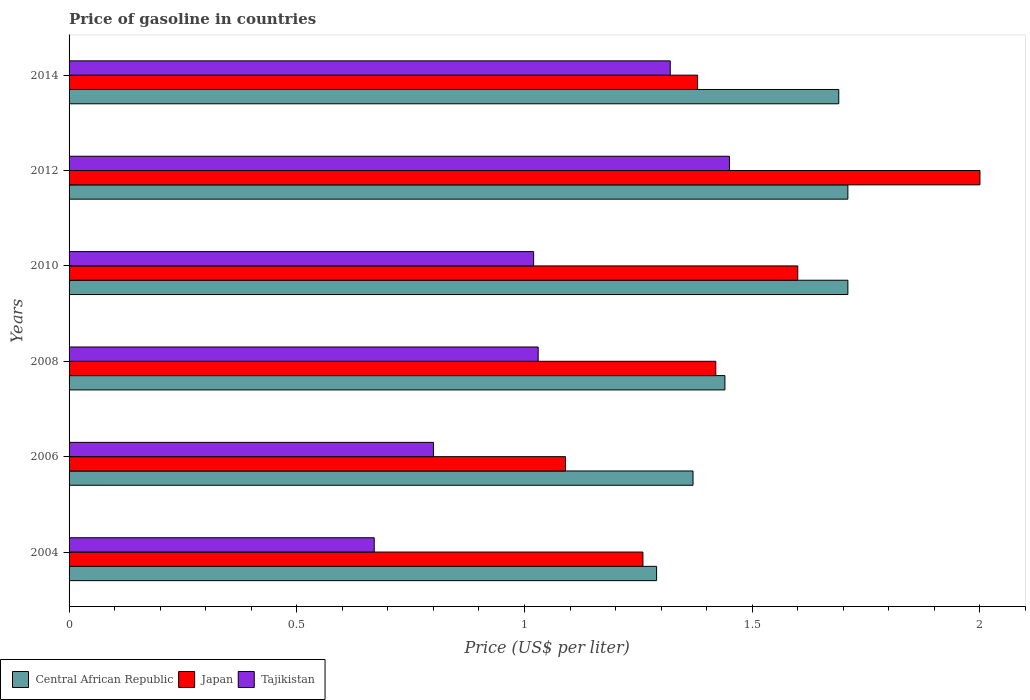Are the number of bars per tick equal to the number of legend labels?
Your answer should be compact. Yes. Across all years, what is the maximum price of gasoline in Tajikistan?
Ensure brevity in your answer.  1.45. Across all years, what is the minimum price of gasoline in Japan?
Give a very brief answer. 1.09. In which year was the price of gasoline in Central African Republic maximum?
Offer a very short reply. 2010. What is the total price of gasoline in Central African Republic in the graph?
Keep it short and to the point. 9.21. What is the difference between the price of gasoline in Tajikistan in 2004 and that in 2006?
Provide a succinct answer. -0.13. What is the difference between the price of gasoline in Tajikistan in 2004 and the price of gasoline in Central African Republic in 2012?
Ensure brevity in your answer.  -1.04. What is the average price of gasoline in Central African Republic per year?
Your response must be concise. 1.53. In the year 2010, what is the difference between the price of gasoline in Tajikistan and price of gasoline in Central African Republic?
Your answer should be compact. -0.69. In how many years, is the price of gasoline in Japan greater than 2 US$?
Offer a very short reply. 0. What is the ratio of the price of gasoline in Japan in 2004 to that in 2014?
Your answer should be compact. 0.91. Is the price of gasoline in Japan in 2010 less than that in 2014?
Your response must be concise. No. Is the difference between the price of gasoline in Tajikistan in 2010 and 2012 greater than the difference between the price of gasoline in Central African Republic in 2010 and 2012?
Give a very brief answer. No. What is the difference between the highest and the second highest price of gasoline in Japan?
Make the answer very short. 0.4. What is the difference between the highest and the lowest price of gasoline in Japan?
Your answer should be very brief. 0.91. Is the sum of the price of gasoline in Central African Republic in 2004 and 2012 greater than the maximum price of gasoline in Tajikistan across all years?
Your answer should be compact. Yes. What does the 2nd bar from the top in 2004 represents?
Provide a succinct answer. Japan. What does the 3rd bar from the bottom in 2014 represents?
Make the answer very short. Tajikistan. Is it the case that in every year, the sum of the price of gasoline in Japan and price of gasoline in Tajikistan is greater than the price of gasoline in Central African Republic?
Offer a terse response. Yes. How many years are there in the graph?
Make the answer very short. 6. What is the difference between two consecutive major ticks on the X-axis?
Give a very brief answer. 0.5. Are the values on the major ticks of X-axis written in scientific E-notation?
Your answer should be very brief. No. Does the graph contain any zero values?
Your answer should be very brief. No. Does the graph contain grids?
Your response must be concise. No. Where does the legend appear in the graph?
Your answer should be compact. Bottom left. How many legend labels are there?
Offer a terse response. 3. What is the title of the graph?
Ensure brevity in your answer.  Price of gasoline in countries. Does "Macedonia" appear as one of the legend labels in the graph?
Your response must be concise. No. What is the label or title of the X-axis?
Your answer should be compact. Price (US$ per liter). What is the Price (US$ per liter) in Central African Republic in 2004?
Keep it short and to the point. 1.29. What is the Price (US$ per liter) in Japan in 2004?
Ensure brevity in your answer.  1.26. What is the Price (US$ per liter) of Tajikistan in 2004?
Offer a very short reply. 0.67. What is the Price (US$ per liter) of Central African Republic in 2006?
Offer a terse response. 1.37. What is the Price (US$ per liter) of Japan in 2006?
Give a very brief answer. 1.09. What is the Price (US$ per liter) in Tajikistan in 2006?
Your answer should be compact. 0.8. What is the Price (US$ per liter) in Central African Republic in 2008?
Give a very brief answer. 1.44. What is the Price (US$ per liter) in Japan in 2008?
Give a very brief answer. 1.42. What is the Price (US$ per liter) in Tajikistan in 2008?
Provide a succinct answer. 1.03. What is the Price (US$ per liter) of Central African Republic in 2010?
Keep it short and to the point. 1.71. What is the Price (US$ per liter) in Tajikistan in 2010?
Provide a short and direct response. 1.02. What is the Price (US$ per liter) in Central African Republic in 2012?
Your response must be concise. 1.71. What is the Price (US$ per liter) in Japan in 2012?
Offer a terse response. 2. What is the Price (US$ per liter) in Tajikistan in 2012?
Your response must be concise. 1.45. What is the Price (US$ per liter) in Central African Republic in 2014?
Offer a very short reply. 1.69. What is the Price (US$ per liter) in Japan in 2014?
Your answer should be compact. 1.38. What is the Price (US$ per liter) in Tajikistan in 2014?
Make the answer very short. 1.32. Across all years, what is the maximum Price (US$ per liter) of Central African Republic?
Ensure brevity in your answer.  1.71. Across all years, what is the maximum Price (US$ per liter) of Japan?
Offer a terse response. 2. Across all years, what is the maximum Price (US$ per liter) of Tajikistan?
Provide a succinct answer. 1.45. Across all years, what is the minimum Price (US$ per liter) of Central African Republic?
Make the answer very short. 1.29. Across all years, what is the minimum Price (US$ per liter) in Japan?
Keep it short and to the point. 1.09. Across all years, what is the minimum Price (US$ per liter) of Tajikistan?
Give a very brief answer. 0.67. What is the total Price (US$ per liter) of Central African Republic in the graph?
Your answer should be very brief. 9.21. What is the total Price (US$ per liter) in Japan in the graph?
Ensure brevity in your answer.  8.75. What is the total Price (US$ per liter) of Tajikistan in the graph?
Provide a short and direct response. 6.29. What is the difference between the Price (US$ per liter) of Central African Republic in 2004 and that in 2006?
Offer a terse response. -0.08. What is the difference between the Price (US$ per liter) of Japan in 2004 and that in 2006?
Provide a short and direct response. 0.17. What is the difference between the Price (US$ per liter) in Tajikistan in 2004 and that in 2006?
Keep it short and to the point. -0.13. What is the difference between the Price (US$ per liter) in Japan in 2004 and that in 2008?
Make the answer very short. -0.16. What is the difference between the Price (US$ per liter) in Tajikistan in 2004 and that in 2008?
Provide a short and direct response. -0.36. What is the difference between the Price (US$ per liter) of Central African Republic in 2004 and that in 2010?
Provide a succinct answer. -0.42. What is the difference between the Price (US$ per liter) of Japan in 2004 and that in 2010?
Your response must be concise. -0.34. What is the difference between the Price (US$ per liter) in Tajikistan in 2004 and that in 2010?
Provide a succinct answer. -0.35. What is the difference between the Price (US$ per liter) in Central African Republic in 2004 and that in 2012?
Give a very brief answer. -0.42. What is the difference between the Price (US$ per liter) in Japan in 2004 and that in 2012?
Offer a terse response. -0.74. What is the difference between the Price (US$ per liter) of Tajikistan in 2004 and that in 2012?
Make the answer very short. -0.78. What is the difference between the Price (US$ per liter) in Central African Republic in 2004 and that in 2014?
Make the answer very short. -0.4. What is the difference between the Price (US$ per liter) of Japan in 2004 and that in 2014?
Provide a succinct answer. -0.12. What is the difference between the Price (US$ per liter) in Tajikistan in 2004 and that in 2014?
Provide a succinct answer. -0.65. What is the difference between the Price (US$ per liter) in Central African Republic in 2006 and that in 2008?
Offer a terse response. -0.07. What is the difference between the Price (US$ per liter) in Japan in 2006 and that in 2008?
Keep it short and to the point. -0.33. What is the difference between the Price (US$ per liter) of Tajikistan in 2006 and that in 2008?
Offer a terse response. -0.23. What is the difference between the Price (US$ per liter) in Central African Republic in 2006 and that in 2010?
Ensure brevity in your answer.  -0.34. What is the difference between the Price (US$ per liter) of Japan in 2006 and that in 2010?
Make the answer very short. -0.51. What is the difference between the Price (US$ per liter) of Tajikistan in 2006 and that in 2010?
Provide a succinct answer. -0.22. What is the difference between the Price (US$ per liter) of Central African Republic in 2006 and that in 2012?
Offer a terse response. -0.34. What is the difference between the Price (US$ per liter) of Japan in 2006 and that in 2012?
Your answer should be very brief. -0.91. What is the difference between the Price (US$ per liter) in Tajikistan in 2006 and that in 2012?
Your answer should be very brief. -0.65. What is the difference between the Price (US$ per liter) in Central African Republic in 2006 and that in 2014?
Offer a terse response. -0.32. What is the difference between the Price (US$ per liter) in Japan in 2006 and that in 2014?
Keep it short and to the point. -0.29. What is the difference between the Price (US$ per liter) in Tajikistan in 2006 and that in 2014?
Keep it short and to the point. -0.52. What is the difference between the Price (US$ per liter) of Central African Republic in 2008 and that in 2010?
Keep it short and to the point. -0.27. What is the difference between the Price (US$ per liter) in Japan in 2008 and that in 2010?
Provide a short and direct response. -0.18. What is the difference between the Price (US$ per liter) in Central African Republic in 2008 and that in 2012?
Your response must be concise. -0.27. What is the difference between the Price (US$ per liter) in Japan in 2008 and that in 2012?
Offer a very short reply. -0.58. What is the difference between the Price (US$ per liter) of Tajikistan in 2008 and that in 2012?
Your response must be concise. -0.42. What is the difference between the Price (US$ per liter) of Tajikistan in 2008 and that in 2014?
Ensure brevity in your answer.  -0.29. What is the difference between the Price (US$ per liter) of Central African Republic in 2010 and that in 2012?
Give a very brief answer. 0. What is the difference between the Price (US$ per liter) in Japan in 2010 and that in 2012?
Provide a succinct answer. -0.4. What is the difference between the Price (US$ per liter) of Tajikistan in 2010 and that in 2012?
Give a very brief answer. -0.43. What is the difference between the Price (US$ per liter) in Japan in 2010 and that in 2014?
Offer a very short reply. 0.22. What is the difference between the Price (US$ per liter) of Tajikistan in 2010 and that in 2014?
Provide a succinct answer. -0.3. What is the difference between the Price (US$ per liter) of Japan in 2012 and that in 2014?
Provide a short and direct response. 0.62. What is the difference between the Price (US$ per liter) in Tajikistan in 2012 and that in 2014?
Your answer should be very brief. 0.13. What is the difference between the Price (US$ per liter) of Central African Republic in 2004 and the Price (US$ per liter) of Japan in 2006?
Your answer should be compact. 0.2. What is the difference between the Price (US$ per liter) in Central African Republic in 2004 and the Price (US$ per liter) in Tajikistan in 2006?
Your answer should be compact. 0.49. What is the difference between the Price (US$ per liter) of Japan in 2004 and the Price (US$ per liter) of Tajikistan in 2006?
Your response must be concise. 0.46. What is the difference between the Price (US$ per liter) in Central African Republic in 2004 and the Price (US$ per liter) in Japan in 2008?
Keep it short and to the point. -0.13. What is the difference between the Price (US$ per liter) in Central African Republic in 2004 and the Price (US$ per liter) in Tajikistan in 2008?
Offer a terse response. 0.26. What is the difference between the Price (US$ per liter) of Japan in 2004 and the Price (US$ per liter) of Tajikistan in 2008?
Provide a succinct answer. 0.23. What is the difference between the Price (US$ per liter) in Central African Republic in 2004 and the Price (US$ per liter) in Japan in 2010?
Make the answer very short. -0.31. What is the difference between the Price (US$ per liter) of Central African Republic in 2004 and the Price (US$ per liter) of Tajikistan in 2010?
Your answer should be compact. 0.27. What is the difference between the Price (US$ per liter) of Japan in 2004 and the Price (US$ per liter) of Tajikistan in 2010?
Give a very brief answer. 0.24. What is the difference between the Price (US$ per liter) of Central African Republic in 2004 and the Price (US$ per liter) of Japan in 2012?
Your answer should be compact. -0.71. What is the difference between the Price (US$ per liter) of Central African Republic in 2004 and the Price (US$ per liter) of Tajikistan in 2012?
Offer a very short reply. -0.16. What is the difference between the Price (US$ per liter) in Japan in 2004 and the Price (US$ per liter) in Tajikistan in 2012?
Offer a very short reply. -0.19. What is the difference between the Price (US$ per liter) of Central African Republic in 2004 and the Price (US$ per liter) of Japan in 2014?
Offer a terse response. -0.09. What is the difference between the Price (US$ per liter) of Central African Republic in 2004 and the Price (US$ per liter) of Tajikistan in 2014?
Provide a short and direct response. -0.03. What is the difference between the Price (US$ per liter) in Japan in 2004 and the Price (US$ per liter) in Tajikistan in 2014?
Your answer should be compact. -0.06. What is the difference between the Price (US$ per liter) in Central African Republic in 2006 and the Price (US$ per liter) in Tajikistan in 2008?
Your response must be concise. 0.34. What is the difference between the Price (US$ per liter) of Japan in 2006 and the Price (US$ per liter) of Tajikistan in 2008?
Give a very brief answer. 0.06. What is the difference between the Price (US$ per liter) of Central African Republic in 2006 and the Price (US$ per liter) of Japan in 2010?
Make the answer very short. -0.23. What is the difference between the Price (US$ per liter) of Japan in 2006 and the Price (US$ per liter) of Tajikistan in 2010?
Provide a short and direct response. 0.07. What is the difference between the Price (US$ per liter) in Central African Republic in 2006 and the Price (US$ per liter) in Japan in 2012?
Offer a very short reply. -0.63. What is the difference between the Price (US$ per liter) in Central African Republic in 2006 and the Price (US$ per liter) in Tajikistan in 2012?
Provide a short and direct response. -0.08. What is the difference between the Price (US$ per liter) of Japan in 2006 and the Price (US$ per liter) of Tajikistan in 2012?
Make the answer very short. -0.36. What is the difference between the Price (US$ per liter) in Central African Republic in 2006 and the Price (US$ per liter) in Japan in 2014?
Offer a very short reply. -0.01. What is the difference between the Price (US$ per liter) of Japan in 2006 and the Price (US$ per liter) of Tajikistan in 2014?
Give a very brief answer. -0.23. What is the difference between the Price (US$ per liter) of Central African Republic in 2008 and the Price (US$ per liter) of Japan in 2010?
Provide a succinct answer. -0.16. What is the difference between the Price (US$ per liter) of Central African Republic in 2008 and the Price (US$ per liter) of Tajikistan in 2010?
Provide a short and direct response. 0.42. What is the difference between the Price (US$ per liter) of Central African Republic in 2008 and the Price (US$ per liter) of Japan in 2012?
Your response must be concise. -0.56. What is the difference between the Price (US$ per liter) of Central African Republic in 2008 and the Price (US$ per liter) of Tajikistan in 2012?
Make the answer very short. -0.01. What is the difference between the Price (US$ per liter) of Japan in 2008 and the Price (US$ per liter) of Tajikistan in 2012?
Offer a terse response. -0.03. What is the difference between the Price (US$ per liter) in Central African Republic in 2008 and the Price (US$ per liter) in Japan in 2014?
Offer a terse response. 0.06. What is the difference between the Price (US$ per liter) in Central African Republic in 2008 and the Price (US$ per liter) in Tajikistan in 2014?
Your answer should be very brief. 0.12. What is the difference between the Price (US$ per liter) in Central African Republic in 2010 and the Price (US$ per liter) in Japan in 2012?
Offer a terse response. -0.29. What is the difference between the Price (US$ per liter) of Central African Republic in 2010 and the Price (US$ per liter) of Tajikistan in 2012?
Make the answer very short. 0.26. What is the difference between the Price (US$ per liter) in Central African Republic in 2010 and the Price (US$ per liter) in Japan in 2014?
Keep it short and to the point. 0.33. What is the difference between the Price (US$ per liter) of Central African Republic in 2010 and the Price (US$ per liter) of Tajikistan in 2014?
Your response must be concise. 0.39. What is the difference between the Price (US$ per liter) in Japan in 2010 and the Price (US$ per liter) in Tajikistan in 2014?
Make the answer very short. 0.28. What is the difference between the Price (US$ per liter) of Central African Republic in 2012 and the Price (US$ per liter) of Japan in 2014?
Your response must be concise. 0.33. What is the difference between the Price (US$ per liter) in Central African Republic in 2012 and the Price (US$ per liter) in Tajikistan in 2014?
Your response must be concise. 0.39. What is the difference between the Price (US$ per liter) of Japan in 2012 and the Price (US$ per liter) of Tajikistan in 2014?
Ensure brevity in your answer.  0.68. What is the average Price (US$ per liter) in Central African Republic per year?
Give a very brief answer. 1.53. What is the average Price (US$ per liter) in Japan per year?
Your answer should be compact. 1.46. What is the average Price (US$ per liter) in Tajikistan per year?
Provide a short and direct response. 1.05. In the year 2004, what is the difference between the Price (US$ per liter) of Central African Republic and Price (US$ per liter) of Tajikistan?
Make the answer very short. 0.62. In the year 2004, what is the difference between the Price (US$ per liter) in Japan and Price (US$ per liter) in Tajikistan?
Provide a short and direct response. 0.59. In the year 2006, what is the difference between the Price (US$ per liter) of Central African Republic and Price (US$ per liter) of Japan?
Ensure brevity in your answer.  0.28. In the year 2006, what is the difference between the Price (US$ per liter) of Central African Republic and Price (US$ per liter) of Tajikistan?
Your answer should be very brief. 0.57. In the year 2006, what is the difference between the Price (US$ per liter) in Japan and Price (US$ per liter) in Tajikistan?
Your answer should be compact. 0.29. In the year 2008, what is the difference between the Price (US$ per liter) of Central African Republic and Price (US$ per liter) of Tajikistan?
Offer a very short reply. 0.41. In the year 2008, what is the difference between the Price (US$ per liter) in Japan and Price (US$ per liter) in Tajikistan?
Ensure brevity in your answer.  0.39. In the year 2010, what is the difference between the Price (US$ per liter) of Central African Republic and Price (US$ per liter) of Japan?
Keep it short and to the point. 0.11. In the year 2010, what is the difference between the Price (US$ per liter) of Central African Republic and Price (US$ per liter) of Tajikistan?
Make the answer very short. 0.69. In the year 2010, what is the difference between the Price (US$ per liter) in Japan and Price (US$ per liter) in Tajikistan?
Give a very brief answer. 0.58. In the year 2012, what is the difference between the Price (US$ per liter) of Central African Republic and Price (US$ per liter) of Japan?
Your answer should be compact. -0.29. In the year 2012, what is the difference between the Price (US$ per liter) in Central African Republic and Price (US$ per liter) in Tajikistan?
Ensure brevity in your answer.  0.26. In the year 2012, what is the difference between the Price (US$ per liter) of Japan and Price (US$ per liter) of Tajikistan?
Ensure brevity in your answer.  0.55. In the year 2014, what is the difference between the Price (US$ per liter) of Central African Republic and Price (US$ per liter) of Japan?
Your answer should be very brief. 0.31. In the year 2014, what is the difference between the Price (US$ per liter) in Central African Republic and Price (US$ per liter) in Tajikistan?
Offer a very short reply. 0.37. In the year 2014, what is the difference between the Price (US$ per liter) of Japan and Price (US$ per liter) of Tajikistan?
Your response must be concise. 0.06. What is the ratio of the Price (US$ per liter) in Central African Republic in 2004 to that in 2006?
Keep it short and to the point. 0.94. What is the ratio of the Price (US$ per liter) in Japan in 2004 to that in 2006?
Your answer should be compact. 1.16. What is the ratio of the Price (US$ per liter) in Tajikistan in 2004 to that in 2006?
Provide a short and direct response. 0.84. What is the ratio of the Price (US$ per liter) of Central African Republic in 2004 to that in 2008?
Keep it short and to the point. 0.9. What is the ratio of the Price (US$ per liter) of Japan in 2004 to that in 2008?
Give a very brief answer. 0.89. What is the ratio of the Price (US$ per liter) in Tajikistan in 2004 to that in 2008?
Your response must be concise. 0.65. What is the ratio of the Price (US$ per liter) in Central African Republic in 2004 to that in 2010?
Give a very brief answer. 0.75. What is the ratio of the Price (US$ per liter) in Japan in 2004 to that in 2010?
Offer a very short reply. 0.79. What is the ratio of the Price (US$ per liter) in Tajikistan in 2004 to that in 2010?
Offer a very short reply. 0.66. What is the ratio of the Price (US$ per liter) of Central African Republic in 2004 to that in 2012?
Provide a short and direct response. 0.75. What is the ratio of the Price (US$ per liter) of Japan in 2004 to that in 2012?
Keep it short and to the point. 0.63. What is the ratio of the Price (US$ per liter) in Tajikistan in 2004 to that in 2012?
Keep it short and to the point. 0.46. What is the ratio of the Price (US$ per liter) in Central African Republic in 2004 to that in 2014?
Make the answer very short. 0.76. What is the ratio of the Price (US$ per liter) in Japan in 2004 to that in 2014?
Provide a short and direct response. 0.91. What is the ratio of the Price (US$ per liter) in Tajikistan in 2004 to that in 2014?
Make the answer very short. 0.51. What is the ratio of the Price (US$ per liter) of Central African Republic in 2006 to that in 2008?
Provide a succinct answer. 0.95. What is the ratio of the Price (US$ per liter) in Japan in 2006 to that in 2008?
Your response must be concise. 0.77. What is the ratio of the Price (US$ per liter) in Tajikistan in 2006 to that in 2008?
Keep it short and to the point. 0.78. What is the ratio of the Price (US$ per liter) in Central African Republic in 2006 to that in 2010?
Keep it short and to the point. 0.8. What is the ratio of the Price (US$ per liter) in Japan in 2006 to that in 2010?
Your response must be concise. 0.68. What is the ratio of the Price (US$ per liter) of Tajikistan in 2006 to that in 2010?
Make the answer very short. 0.78. What is the ratio of the Price (US$ per liter) of Central African Republic in 2006 to that in 2012?
Your answer should be very brief. 0.8. What is the ratio of the Price (US$ per liter) in Japan in 2006 to that in 2012?
Your answer should be very brief. 0.55. What is the ratio of the Price (US$ per liter) in Tajikistan in 2006 to that in 2012?
Offer a very short reply. 0.55. What is the ratio of the Price (US$ per liter) of Central African Republic in 2006 to that in 2014?
Make the answer very short. 0.81. What is the ratio of the Price (US$ per liter) in Japan in 2006 to that in 2014?
Ensure brevity in your answer.  0.79. What is the ratio of the Price (US$ per liter) in Tajikistan in 2006 to that in 2014?
Offer a terse response. 0.61. What is the ratio of the Price (US$ per liter) of Central African Republic in 2008 to that in 2010?
Give a very brief answer. 0.84. What is the ratio of the Price (US$ per liter) of Japan in 2008 to that in 2010?
Keep it short and to the point. 0.89. What is the ratio of the Price (US$ per liter) of Tajikistan in 2008 to that in 2010?
Make the answer very short. 1.01. What is the ratio of the Price (US$ per liter) of Central African Republic in 2008 to that in 2012?
Your response must be concise. 0.84. What is the ratio of the Price (US$ per liter) of Japan in 2008 to that in 2012?
Keep it short and to the point. 0.71. What is the ratio of the Price (US$ per liter) in Tajikistan in 2008 to that in 2012?
Your response must be concise. 0.71. What is the ratio of the Price (US$ per liter) in Central African Republic in 2008 to that in 2014?
Provide a succinct answer. 0.85. What is the ratio of the Price (US$ per liter) in Tajikistan in 2008 to that in 2014?
Offer a terse response. 0.78. What is the ratio of the Price (US$ per liter) in Central African Republic in 2010 to that in 2012?
Offer a terse response. 1. What is the ratio of the Price (US$ per liter) of Tajikistan in 2010 to that in 2012?
Ensure brevity in your answer.  0.7. What is the ratio of the Price (US$ per liter) of Central African Republic in 2010 to that in 2014?
Give a very brief answer. 1.01. What is the ratio of the Price (US$ per liter) in Japan in 2010 to that in 2014?
Your answer should be very brief. 1.16. What is the ratio of the Price (US$ per liter) in Tajikistan in 2010 to that in 2014?
Provide a succinct answer. 0.77. What is the ratio of the Price (US$ per liter) of Central African Republic in 2012 to that in 2014?
Make the answer very short. 1.01. What is the ratio of the Price (US$ per liter) of Japan in 2012 to that in 2014?
Your answer should be very brief. 1.45. What is the ratio of the Price (US$ per liter) of Tajikistan in 2012 to that in 2014?
Offer a terse response. 1.1. What is the difference between the highest and the second highest Price (US$ per liter) of Japan?
Keep it short and to the point. 0.4. What is the difference between the highest and the second highest Price (US$ per liter) of Tajikistan?
Your answer should be very brief. 0.13. What is the difference between the highest and the lowest Price (US$ per liter) in Central African Republic?
Ensure brevity in your answer.  0.42. What is the difference between the highest and the lowest Price (US$ per liter) of Japan?
Provide a short and direct response. 0.91. What is the difference between the highest and the lowest Price (US$ per liter) in Tajikistan?
Offer a very short reply. 0.78. 